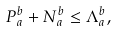Convert formula to latex. <formula><loc_0><loc_0><loc_500><loc_500>P _ { a } ^ { b } + N _ { a } ^ { b } \leq \Lambda _ { a } ^ { b } ,</formula> 